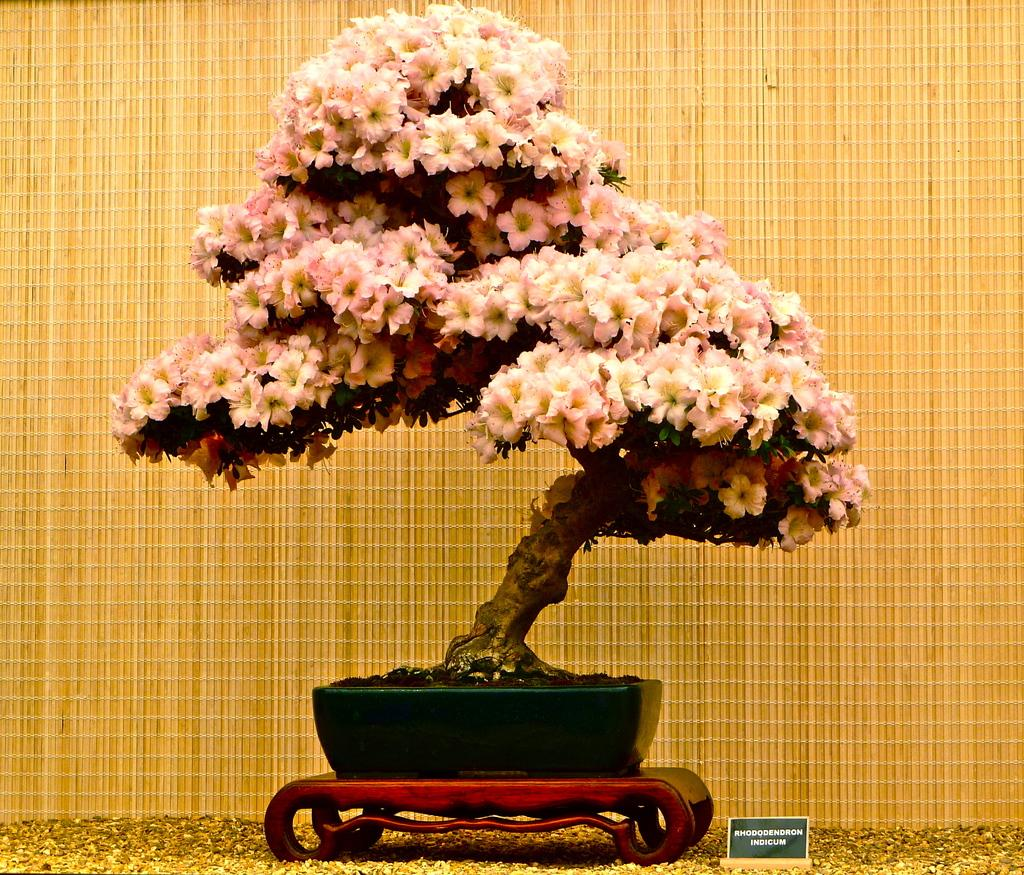What is the main subject in the center of the image? There is a plant in the center of the image. What can be seen at the bottom of the image? There is soil at the bottom of the image. What is visible in the background of the image? There is a mat in the background of the image. Where is the nameplate located in the image? The nameplate is on the right side of the image. What part of the plant is responsible for sparking creativity in the image? There is no indication in the image that the plant has any connection to creativity or sparking creativity. 